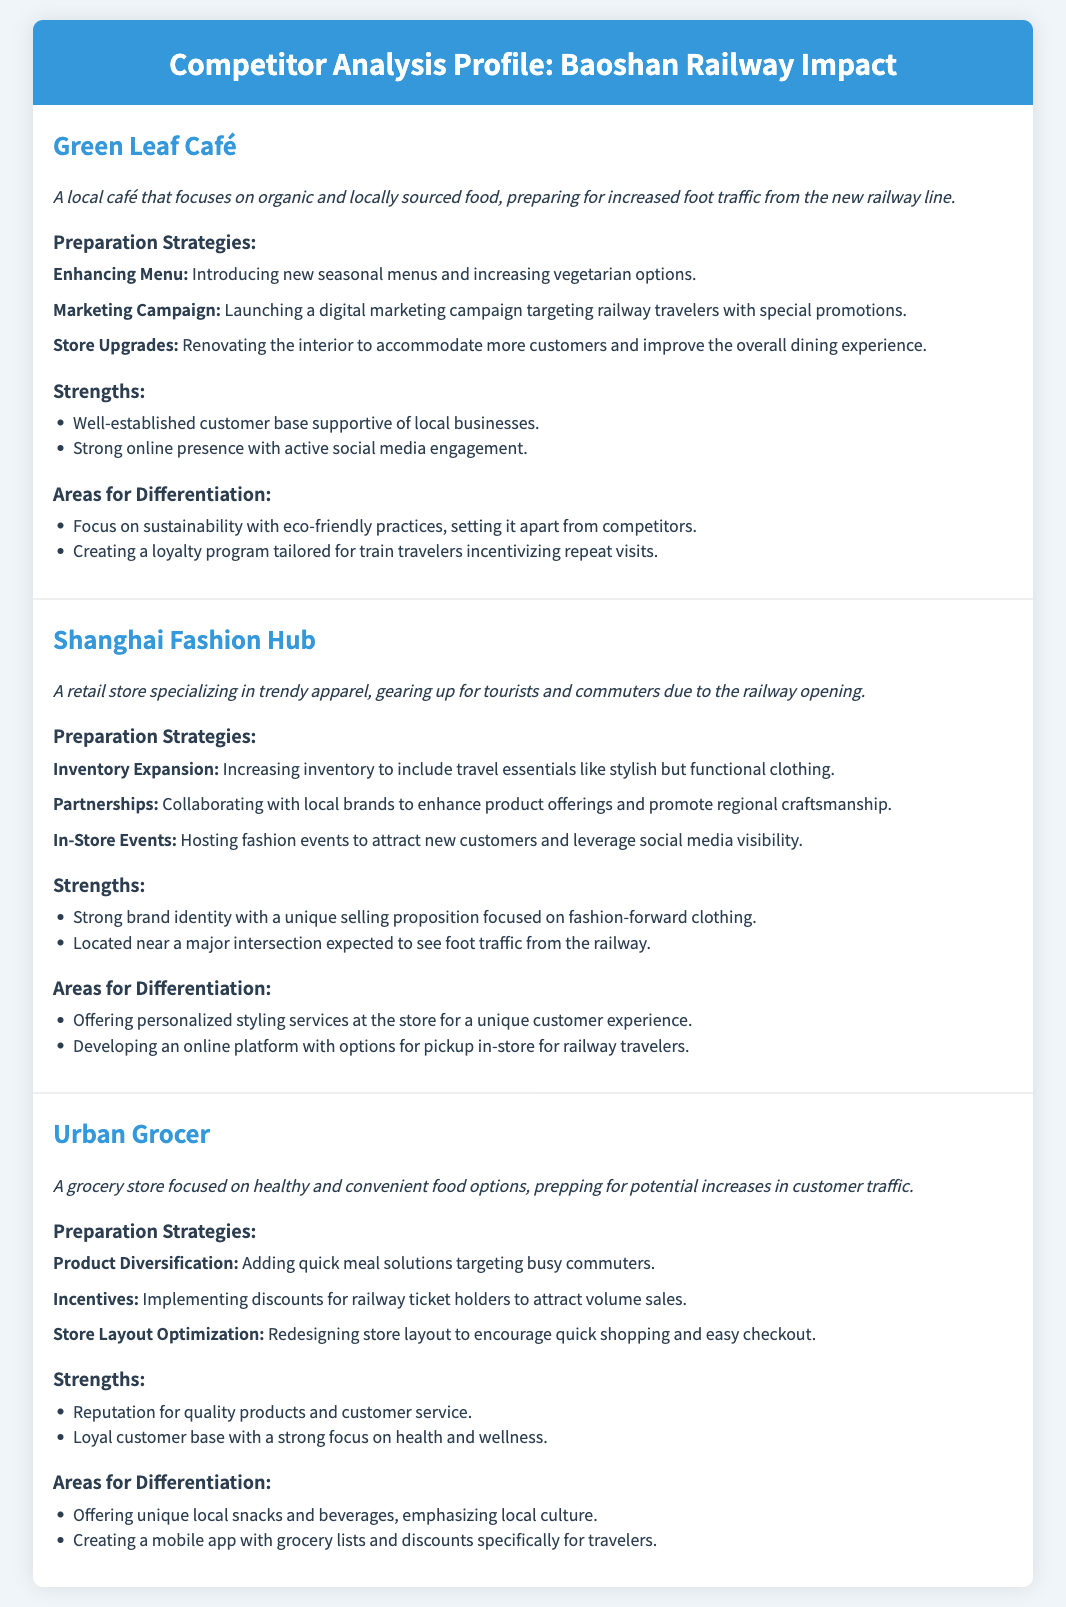What is the name of the café preparing for railway traffic? The café that is preparing for increased foot traffic from the new railway line is called Green Leaf Café.
Answer: Green Leaf Café What unique service is Shanghai Fashion Hub offering? Shanghai Fashion Hub is differentiating itself by offering personalized styling services at the store for a unique customer experience.
Answer: Personalized styling services How is Urban Grocer incentivizing customers? Urban Grocer is implementing discounts for railway ticket holders to attract volume sales.
Answer: Discounts for railway ticket holders Which competitor focuses on sustainability? The competitor that focuses on sustainability with eco-friendly practices is Green Leaf Café.
Answer: Green Leaf Café What product category is Urban Grocer targeting? Urban Grocer is adding quick meal solutions targeting busy commuters.
Answer: Quick meal solutions How many competitors are analyzed in the document? There are three competitors analyzed in the document: Green Leaf Café, Shanghai Fashion Hub, and Urban Grocer.
Answer: Three What type of events is Shanghai Fashion Hub hosting? Shanghai Fashion Hub is hosting fashion events to attract new customers and leverage social media visibility.
Answer: Fashion events Which competitor has a strong online presence? The competitor with a strong online presence with active social media engagement is Green Leaf Café.
Answer: Green Leaf Café 